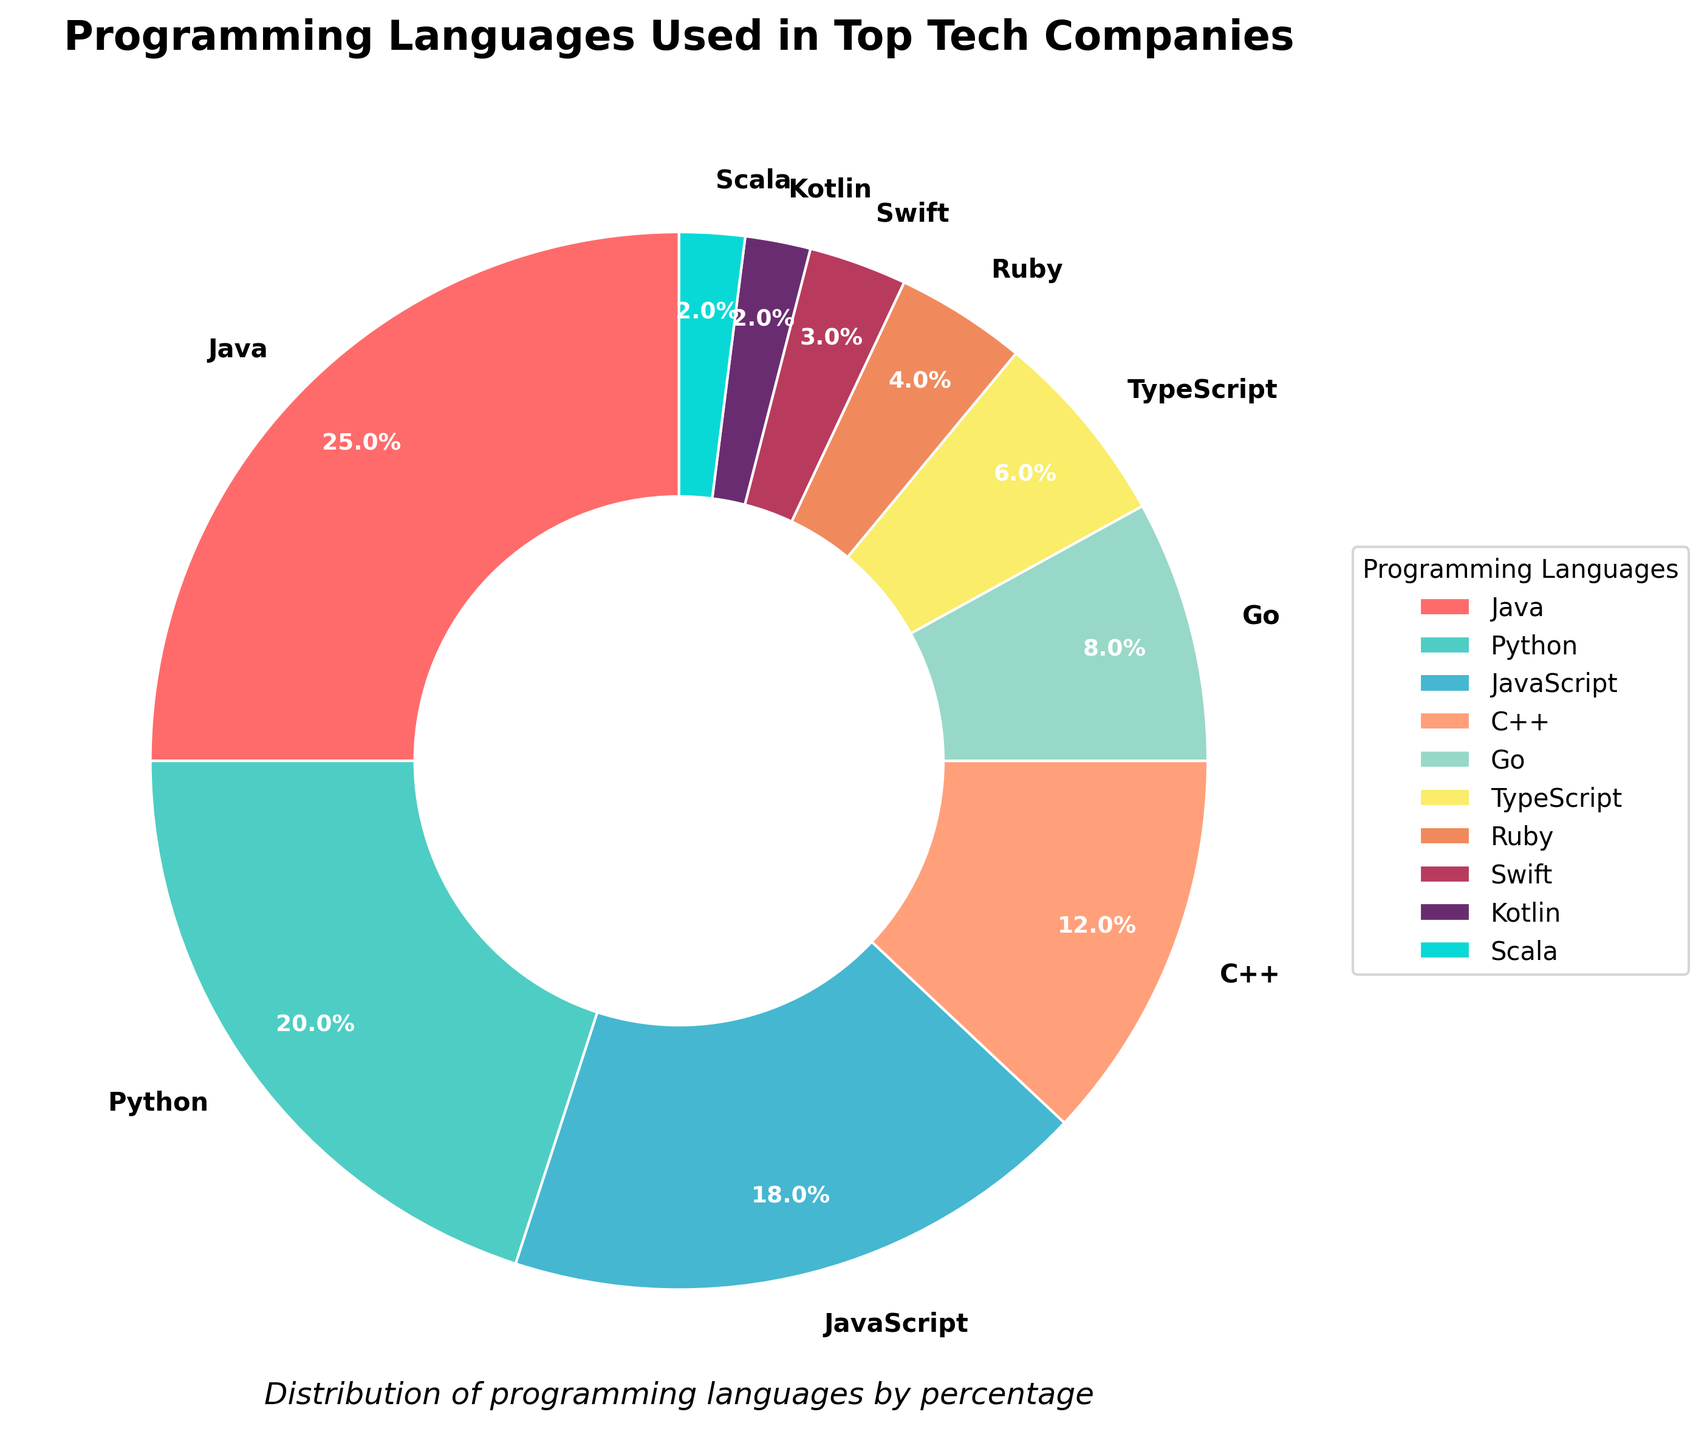What percentage is represented by Python and JavaScript combined? Python accounts for 20% and JavaScript accounts for 18%. Adding these together gives 20% + 18% = 38%.
Answer: 38% Which programming language occupies the smallest percentage? Among the listed languages, Scala and Kotlin both have the smallest percentage, each accounting for 2%.
Answer: Scala and Kotlin Is the percentage of Java greater than twice the percentage of Go? Java accounts for 25%. Go accounts for 8%. Twice the percentage of Go is 16%. Since 25% (Java) is greater than 16% (twice of Go), the answer is yes.
Answer: Yes Which language has a higher percentage, C++ or TypeScript, and by how much? C++ represents 12%, and TypeScript represents 6%. The difference is 12% - 6% = 6%.
Answer: C++ by 6% What are the top three programming languages used in top tech companies based on the percentages? The percentages listed are Java 25%, Python 20%, JavaScript 18%, C++ 12%, Go 8%, TypeScript 6%, Ruby 4%, Swift 3%, Kotlin 2%, Scala 2%. The top three are Java (25%), Python (20%), and JavaScript (18%).
Answer: Java, Python, JavaScript What is the total percentage of languages other than the top three (Java, Python, JavaScript)? The percentages for the remaining languages are C++ 12%, Go 8%, TypeScript 6%, Ruby 4%, Swift 3%, Kotlin 2%, Scala 2%. Adding these gives 12% + 8% + 6% + 4% + 3% + 2% + 2% = 37%.
Answer: 37% Which programming language has an orange wedge, and what is its percentage? The orange wedge corresponds to JavaScript, which accounts for 18%.
Answer: JavaScript, 18% How many programming languages listed each have less than 5% usage? Ruby (4%), Swift (3%), Kotlin (2%), and Scala (2%) all have less than 5% usage. Counting them gives 4 languages.
Answer: 4 languages 